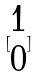<formula> <loc_0><loc_0><loc_500><loc_500>[ \begin{matrix} 1 \\ 0 \end{matrix} ]</formula> 